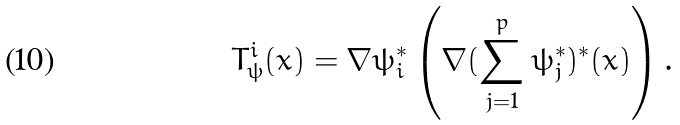<formula> <loc_0><loc_0><loc_500><loc_500>T _ { \psi } ^ { i } ( x ) = \nabla \psi _ { i } ^ { \ast } \left ( \nabla ( \sum _ { j = 1 } ^ { p } \psi _ { j } ^ { \ast } ) ^ { \ast } ( x ) \right ) .</formula> 